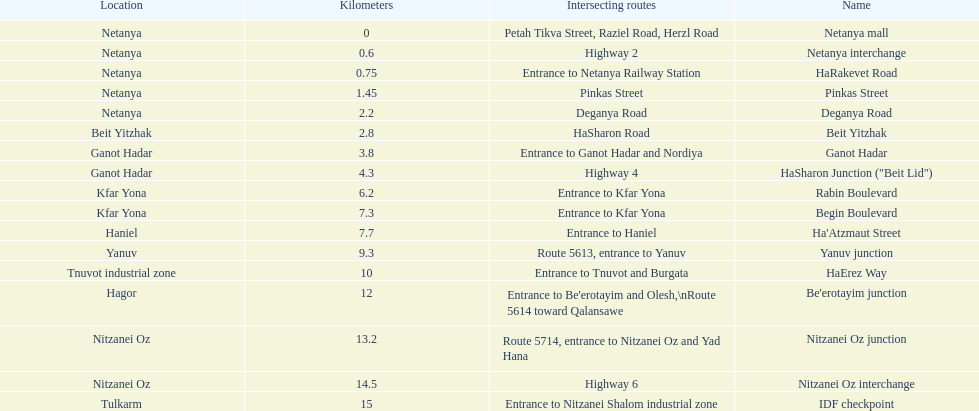Can you give me this table as a dict? {'header': ['Location', 'Kilometers', 'Intersecting routes', 'Name'], 'rows': [['Netanya', '0', 'Petah Tikva Street, Raziel Road, Herzl Road', 'Netanya mall'], ['Netanya', '0.6', 'Highway 2', 'Netanya interchange'], ['Netanya', '0.75', 'Entrance to Netanya Railway Station', 'HaRakevet Road'], ['Netanya', '1.45', 'Pinkas Street', 'Pinkas Street'], ['Netanya', '2.2', 'Deganya Road', 'Deganya Road'], ['Beit Yitzhak', '2.8', 'HaSharon Road', 'Beit Yitzhak'], ['Ganot Hadar', '3.8', 'Entrance to Ganot Hadar and Nordiya', 'Ganot Hadar'], ['Ganot Hadar', '4.3', 'Highway 4', 'HaSharon Junction ("Beit Lid")'], ['Kfar Yona', '6.2', 'Entrance to Kfar Yona', 'Rabin Boulevard'], ['Kfar Yona', '7.3', 'Entrance to Kfar Yona', 'Begin Boulevard'], ['Haniel', '7.7', 'Entrance to Haniel', "Ha'Atzmaut Street"], ['Yanuv', '9.3', 'Route 5613, entrance to Yanuv', 'Yanuv junction'], ['Tnuvot industrial zone', '10', 'Entrance to Tnuvot and Burgata', 'HaErez Way'], ['Hagor', '12', "Entrance to Be'erotayim and Olesh,\\nRoute 5614 toward Qalansawe", "Be'erotayim junction"], ['Nitzanei Oz', '13.2', 'Route 5714, entrance to Nitzanei Oz and Yad Hana', 'Nitzanei Oz junction'], ['Nitzanei Oz', '14.5', 'Highway 6', 'Nitzanei Oz interchange'], ['Tulkarm', '15', 'Entrance to Nitzanei Shalom industrial zone', 'IDF checkpoint']]} How many portions are lo?cated in netanya 5. 